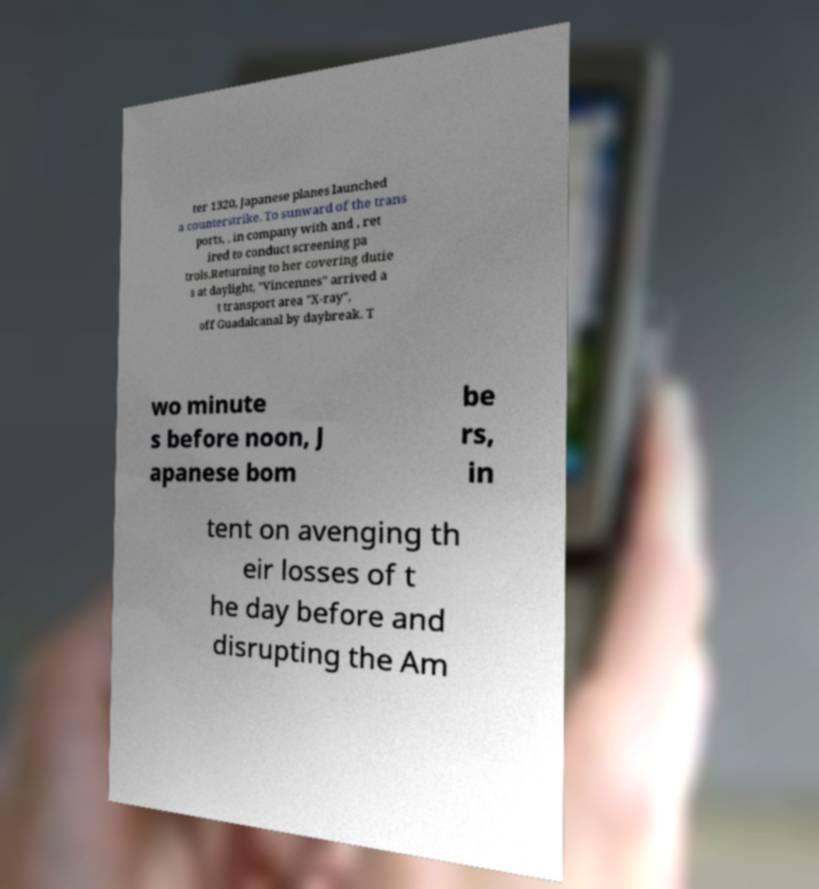Can you accurately transcribe the text from the provided image for me? ter 1320, Japanese planes launched a counterstrike. To sunward of the trans ports, , in company with and , ret ired to conduct screening pa trols.Returning to her covering dutie s at daylight, "Vincennes" arrived a t transport area "X-ray", off Guadalcanal by daybreak. T wo minute s before noon, J apanese bom be rs, in tent on avenging th eir losses of t he day before and disrupting the Am 